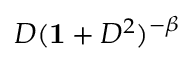<formula> <loc_0><loc_0><loc_500><loc_500>D ( { 1 } + D ^ { 2 } ) ^ { - \beta }</formula> 